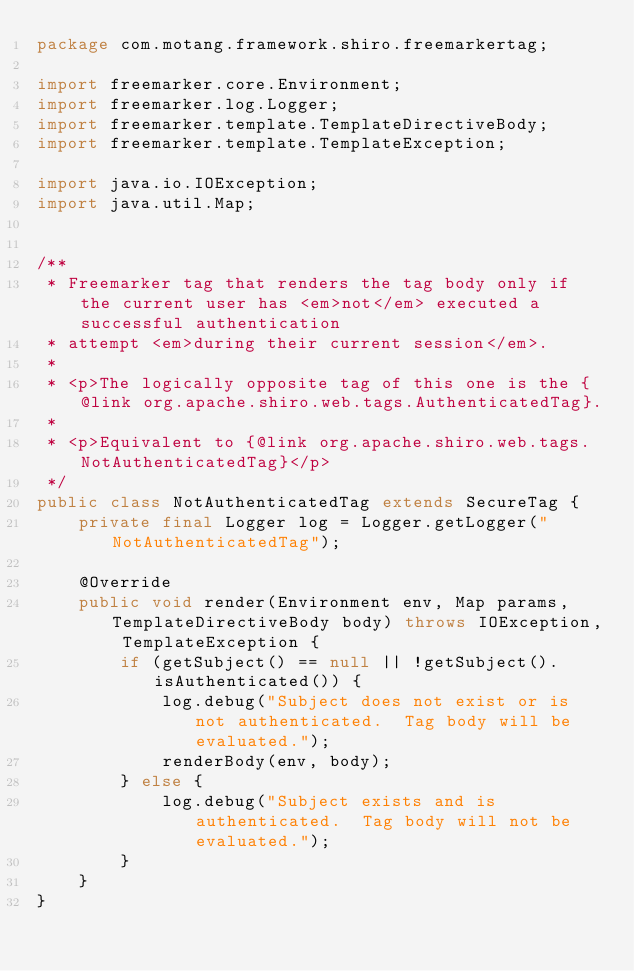Convert code to text. <code><loc_0><loc_0><loc_500><loc_500><_Java_>package com.motang.framework.shiro.freemarkertag;

import freemarker.core.Environment;
import freemarker.log.Logger;
import freemarker.template.TemplateDirectiveBody;
import freemarker.template.TemplateException;

import java.io.IOException;
import java.util.Map;


/**
 * Freemarker tag that renders the tag body only if the current user has <em>not</em> executed a successful authentication
 * attempt <em>during their current session</em>.
 *
 * <p>The logically opposite tag of this one is the {@link org.apache.shiro.web.tags.AuthenticatedTag}.
 *
 * <p>Equivalent to {@link org.apache.shiro.web.tags.NotAuthenticatedTag}</p>
 */
public class NotAuthenticatedTag extends SecureTag {
    private final Logger log = Logger.getLogger("NotAuthenticatedTag");

    @Override
    public void render(Environment env, Map params, TemplateDirectiveBody body) throws IOException, TemplateException {
        if (getSubject() == null || !getSubject().isAuthenticated()) {
            log.debug("Subject does not exist or is not authenticated.  Tag body will be evaluated.");
            renderBody(env, body);
        } else {
            log.debug("Subject exists and is authenticated.  Tag body will not be evaluated.");
        }
    }
}</code> 